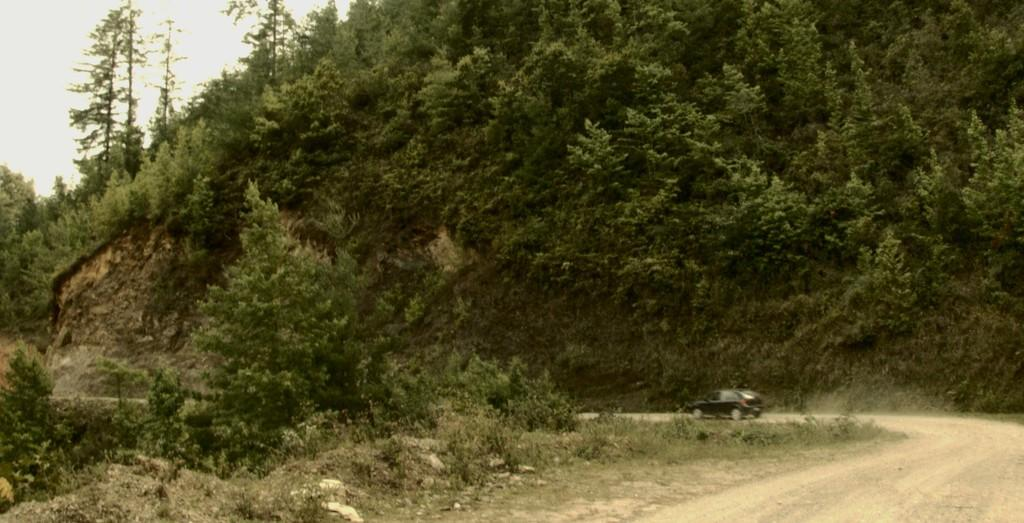What is on the path in the image? There is a car on the path in the image. What type of vegetation can be seen in the image? Trees are visible in the image. What is visible in the background of the image? The sky is visible in the background of the image. What type of reward can be seen hanging from the trees in the image? There are no rewards hanging from the trees in the image; only trees are visible. 